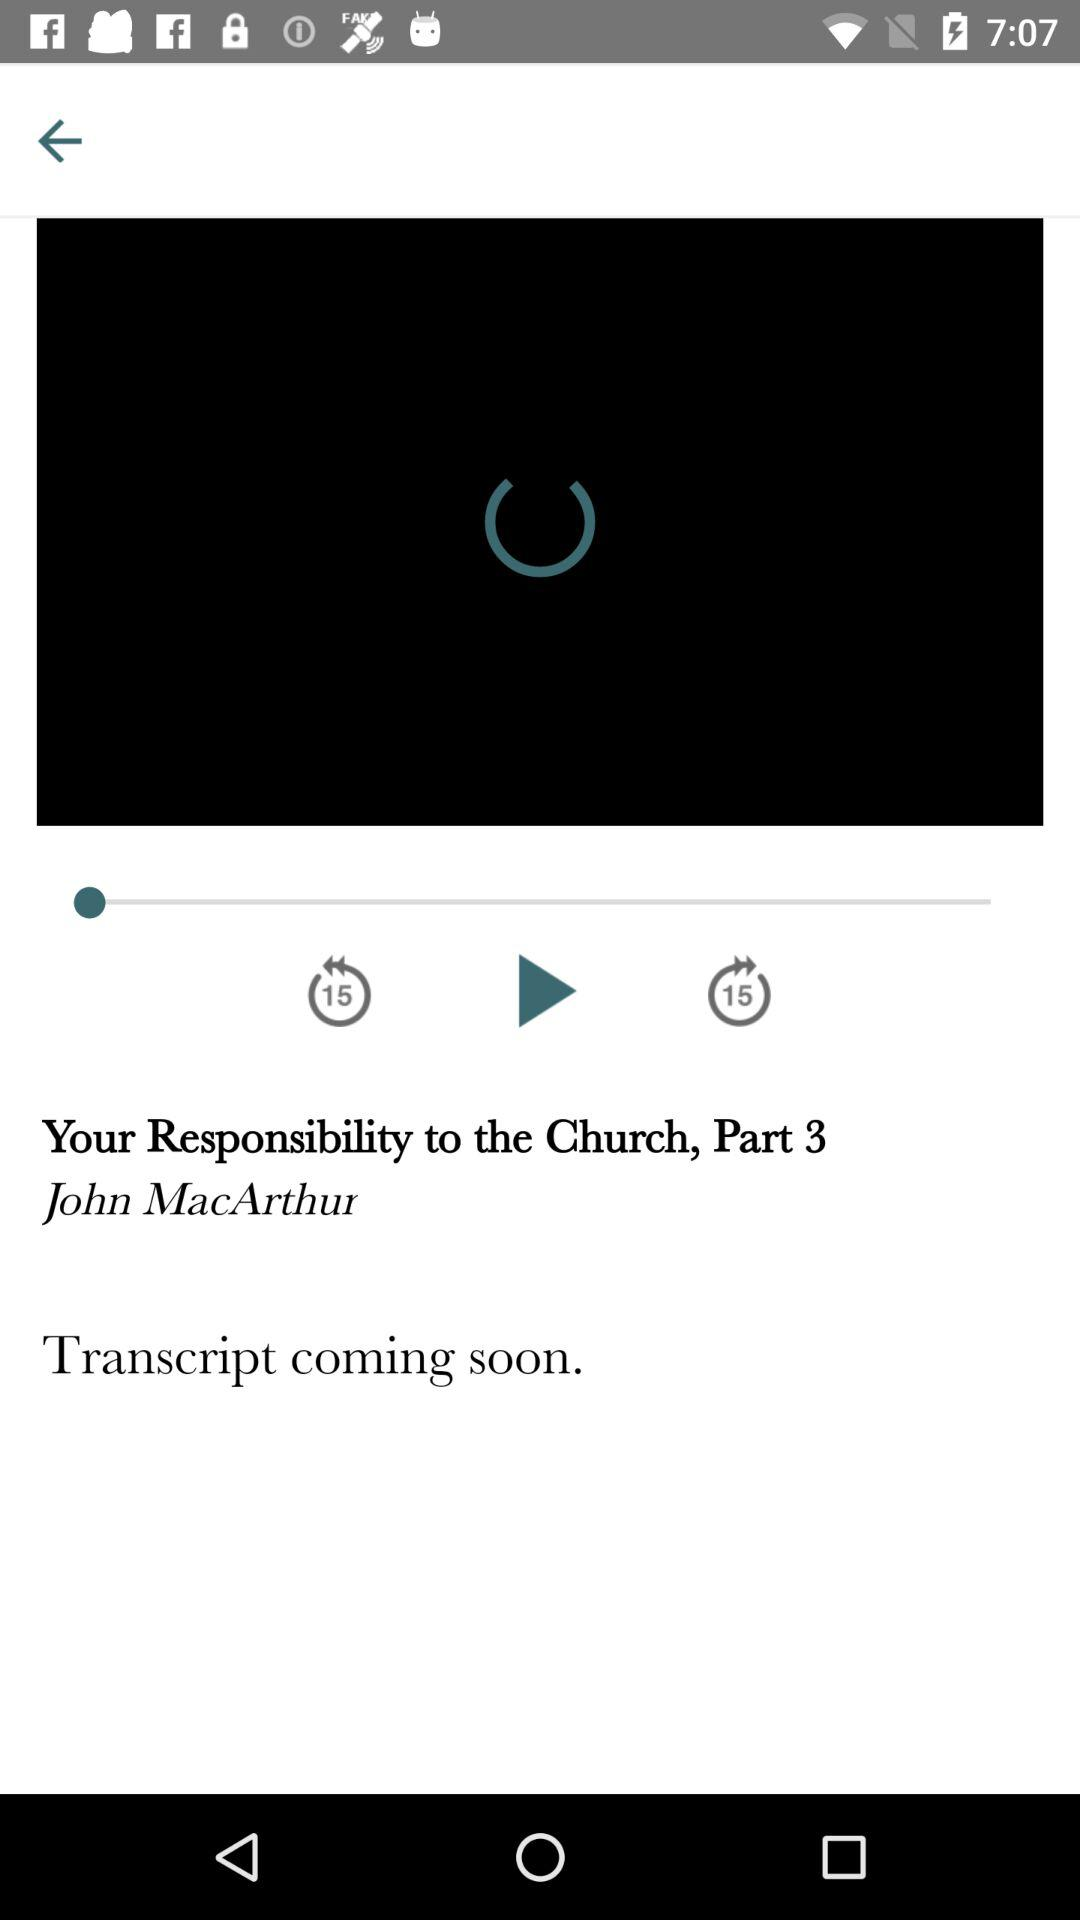What is the author name? The author name is John MacArthur. 